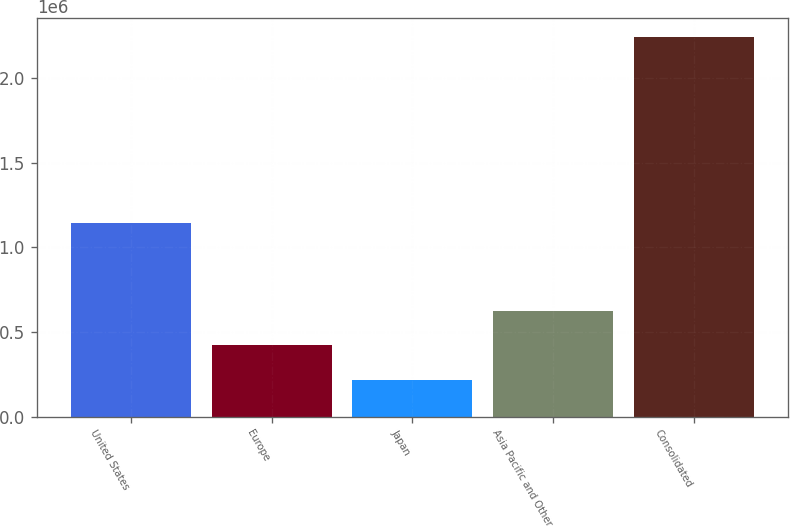Convert chart. <chart><loc_0><loc_0><loc_500><loc_500><bar_chart><fcel>United States<fcel>Europe<fcel>Japan<fcel>Asia Pacific and Other<fcel>Consolidated<nl><fcel>1.14382e+06<fcel>421136<fcel>218794<fcel>623477<fcel>2.24221e+06<nl></chart> 